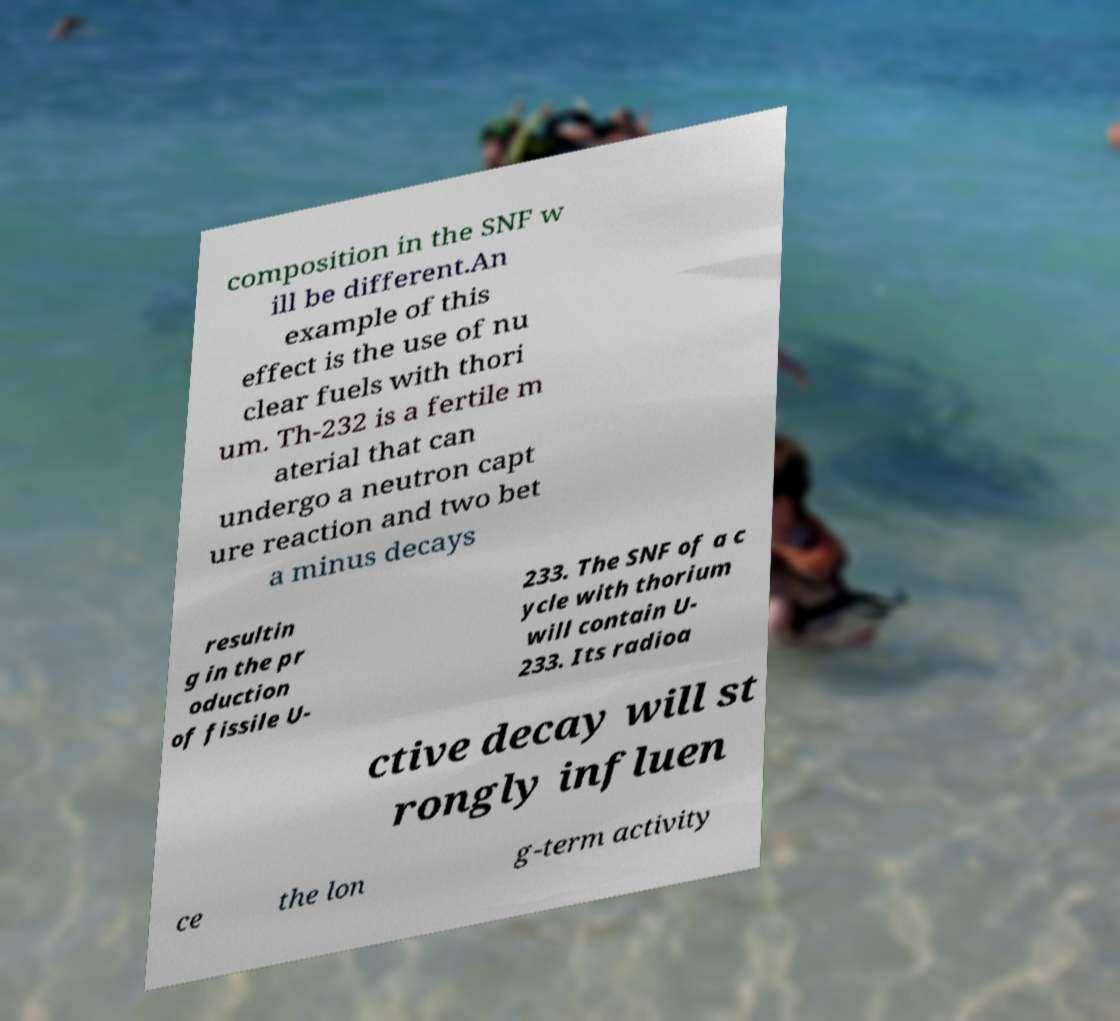Can you accurately transcribe the text from the provided image for me? composition in the SNF w ill be different.An example of this effect is the use of nu clear fuels with thori um. Th-232 is a fertile m aterial that can undergo a neutron capt ure reaction and two bet a minus decays resultin g in the pr oduction of fissile U- 233. The SNF of a c ycle with thorium will contain U- 233. Its radioa ctive decay will st rongly influen ce the lon g-term activity 